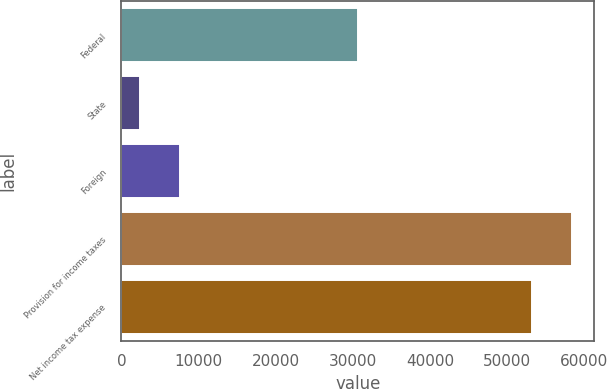Convert chart to OTSL. <chart><loc_0><loc_0><loc_500><loc_500><bar_chart><fcel>Federal<fcel>State<fcel>Foreign<fcel>Provision for income taxes<fcel>Net income tax expense<nl><fcel>30699<fcel>2477<fcel>7564.4<fcel>58369.4<fcel>53282<nl></chart> 